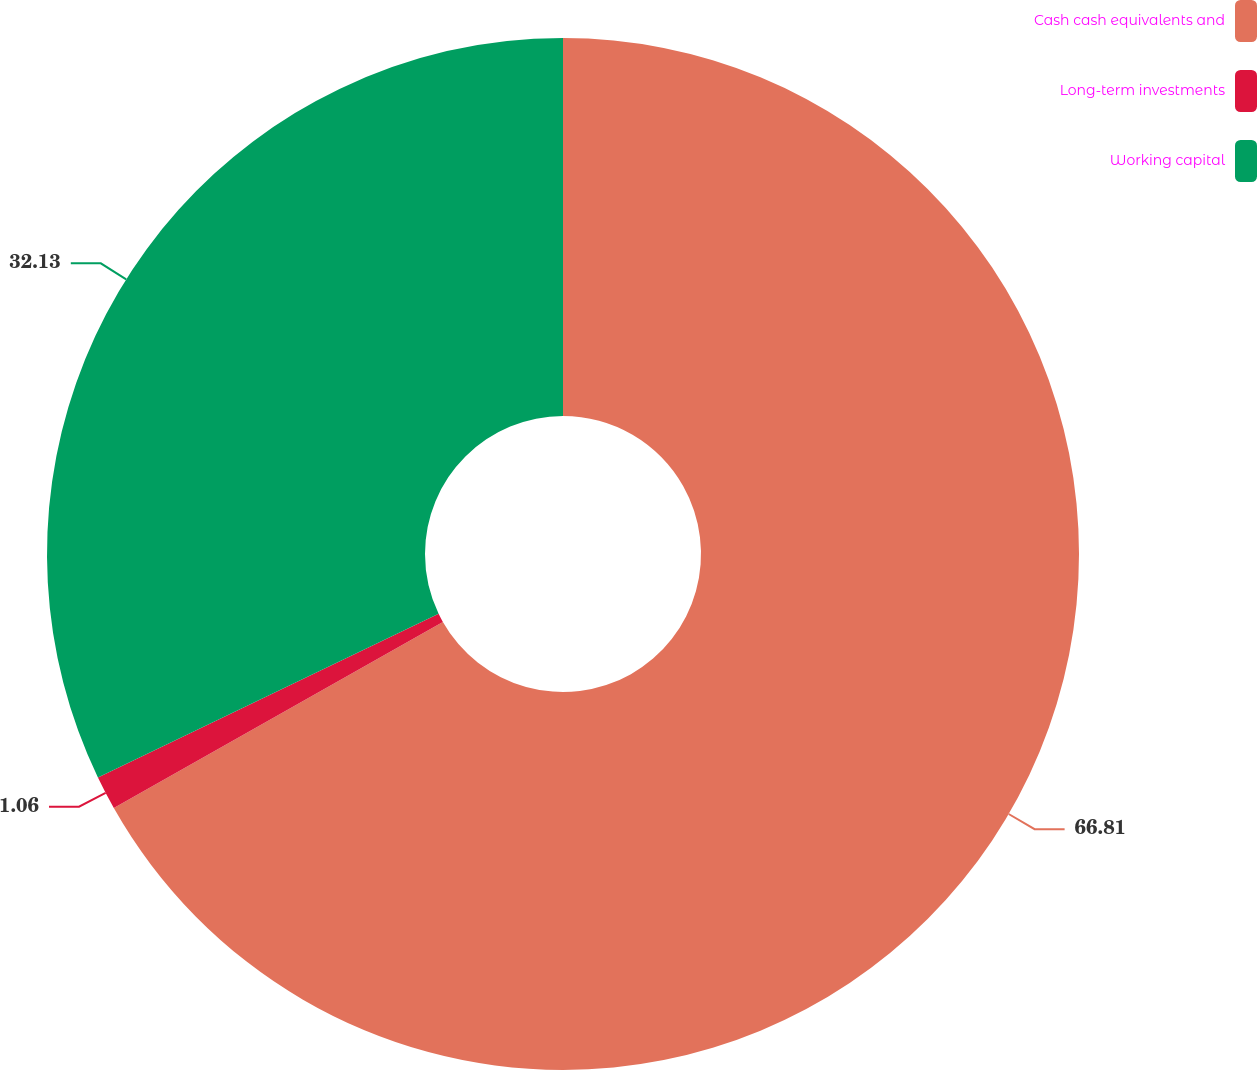Convert chart. <chart><loc_0><loc_0><loc_500><loc_500><pie_chart><fcel>Cash cash equivalents and<fcel>Long-term investments<fcel>Working capital<nl><fcel>66.81%<fcel>1.06%<fcel>32.13%<nl></chart> 